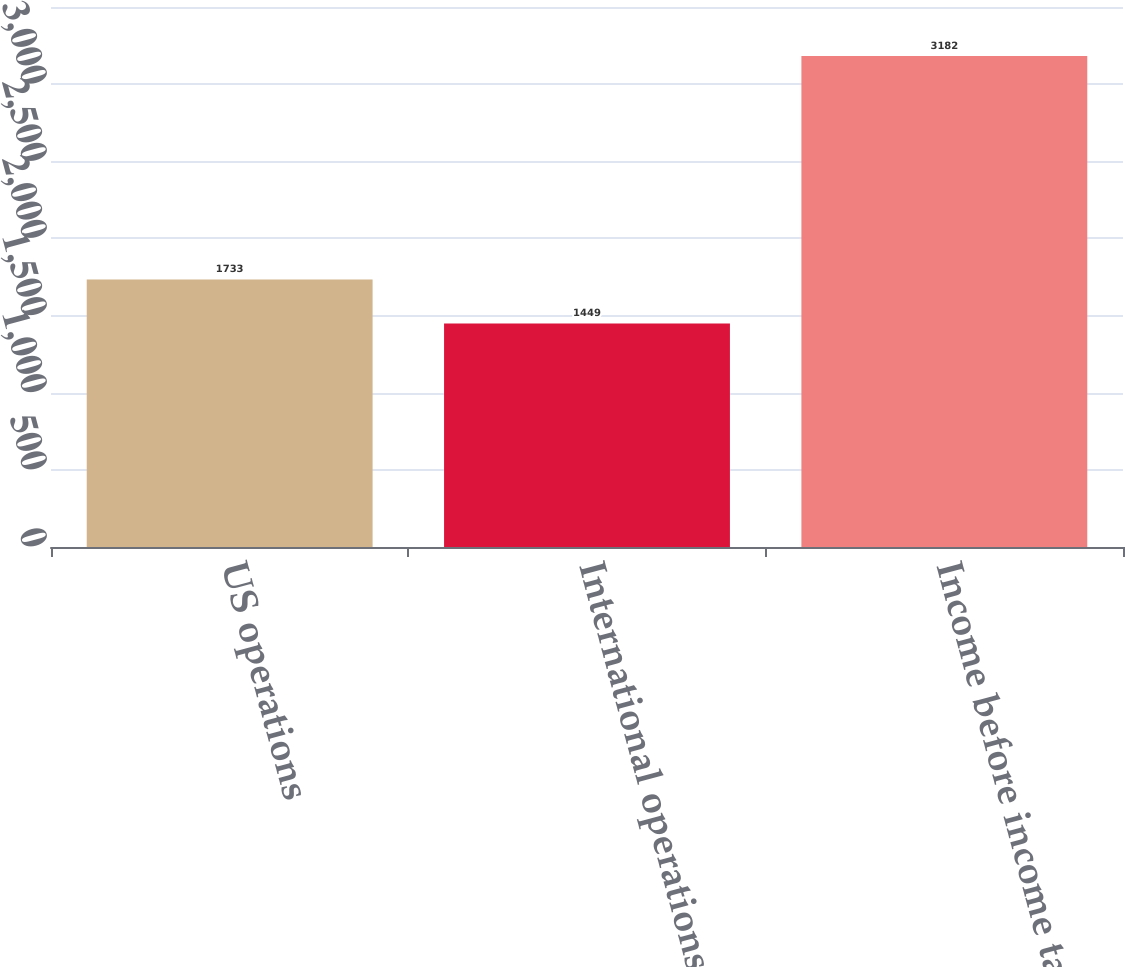Convert chart to OTSL. <chart><loc_0><loc_0><loc_500><loc_500><bar_chart><fcel>US operations<fcel>International operations<fcel>Income before income tax<nl><fcel>1733<fcel>1449<fcel>3182<nl></chart> 